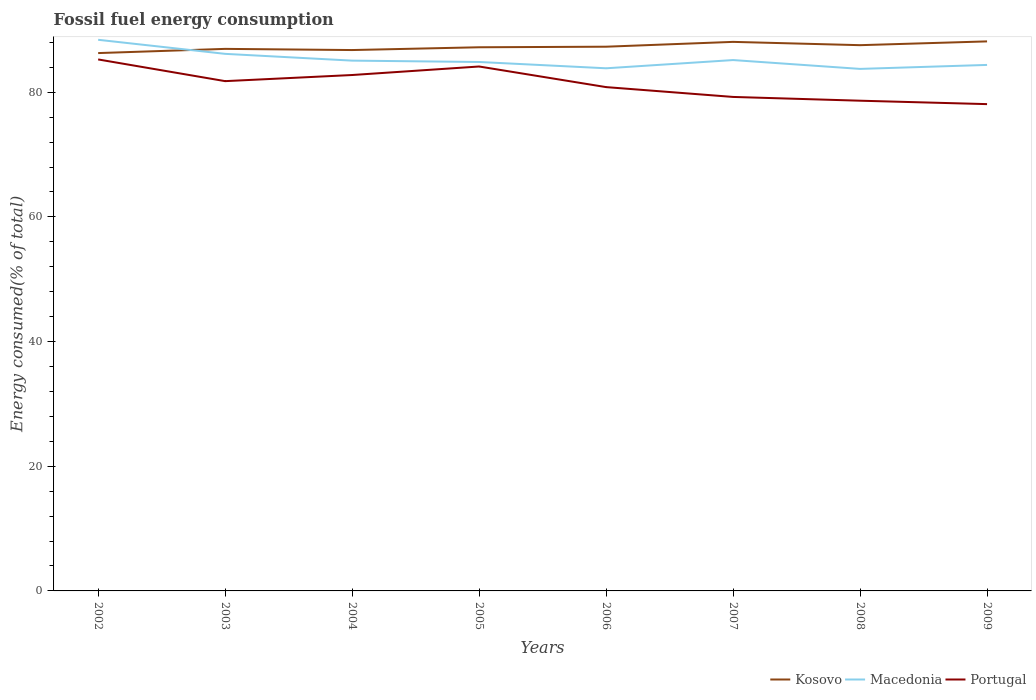Across all years, what is the maximum percentage of energy consumed in Portugal?
Make the answer very short. 78.09. What is the total percentage of energy consumed in Kosovo in the graph?
Provide a short and direct response. -0.08. What is the difference between the highest and the second highest percentage of energy consumed in Portugal?
Your response must be concise. 7.17. Is the percentage of energy consumed in Kosovo strictly greater than the percentage of energy consumed in Portugal over the years?
Ensure brevity in your answer.  No. How many years are there in the graph?
Make the answer very short. 8. How many legend labels are there?
Offer a terse response. 3. What is the title of the graph?
Your answer should be compact. Fossil fuel energy consumption. What is the label or title of the X-axis?
Your response must be concise. Years. What is the label or title of the Y-axis?
Your response must be concise. Energy consumed(% of total). What is the Energy consumed(% of total) in Kosovo in 2002?
Your response must be concise. 86.28. What is the Energy consumed(% of total) in Macedonia in 2002?
Provide a short and direct response. 88.41. What is the Energy consumed(% of total) in Portugal in 2002?
Your answer should be very brief. 85.26. What is the Energy consumed(% of total) of Kosovo in 2003?
Offer a very short reply. 86.95. What is the Energy consumed(% of total) of Macedonia in 2003?
Make the answer very short. 86.15. What is the Energy consumed(% of total) in Portugal in 2003?
Provide a succinct answer. 81.77. What is the Energy consumed(% of total) of Kosovo in 2004?
Your answer should be very brief. 86.76. What is the Energy consumed(% of total) in Macedonia in 2004?
Provide a short and direct response. 85.07. What is the Energy consumed(% of total) in Portugal in 2004?
Give a very brief answer. 82.76. What is the Energy consumed(% of total) of Kosovo in 2005?
Provide a succinct answer. 87.21. What is the Energy consumed(% of total) of Macedonia in 2005?
Give a very brief answer. 84.85. What is the Energy consumed(% of total) in Portugal in 2005?
Offer a terse response. 84.12. What is the Energy consumed(% of total) in Kosovo in 2006?
Offer a terse response. 87.3. What is the Energy consumed(% of total) of Macedonia in 2006?
Your answer should be very brief. 83.84. What is the Energy consumed(% of total) of Portugal in 2006?
Provide a short and direct response. 80.82. What is the Energy consumed(% of total) in Kosovo in 2007?
Ensure brevity in your answer.  88.07. What is the Energy consumed(% of total) of Macedonia in 2007?
Make the answer very short. 85.16. What is the Energy consumed(% of total) of Portugal in 2007?
Offer a very short reply. 79.24. What is the Energy consumed(% of total) of Kosovo in 2008?
Ensure brevity in your answer.  87.54. What is the Energy consumed(% of total) in Macedonia in 2008?
Your answer should be very brief. 83.74. What is the Energy consumed(% of total) of Portugal in 2008?
Give a very brief answer. 78.64. What is the Energy consumed(% of total) of Kosovo in 2009?
Provide a short and direct response. 88.15. What is the Energy consumed(% of total) of Macedonia in 2009?
Your answer should be very brief. 84.38. What is the Energy consumed(% of total) in Portugal in 2009?
Make the answer very short. 78.09. Across all years, what is the maximum Energy consumed(% of total) of Kosovo?
Offer a terse response. 88.15. Across all years, what is the maximum Energy consumed(% of total) of Macedonia?
Give a very brief answer. 88.41. Across all years, what is the maximum Energy consumed(% of total) in Portugal?
Offer a terse response. 85.26. Across all years, what is the minimum Energy consumed(% of total) in Kosovo?
Provide a succinct answer. 86.28. Across all years, what is the minimum Energy consumed(% of total) in Macedonia?
Your answer should be very brief. 83.74. Across all years, what is the minimum Energy consumed(% of total) of Portugal?
Provide a succinct answer. 78.09. What is the total Energy consumed(% of total) in Kosovo in the graph?
Provide a succinct answer. 698.26. What is the total Energy consumed(% of total) in Macedonia in the graph?
Make the answer very short. 681.58. What is the total Energy consumed(% of total) in Portugal in the graph?
Give a very brief answer. 650.69. What is the difference between the Energy consumed(% of total) in Kosovo in 2002 and that in 2003?
Keep it short and to the point. -0.68. What is the difference between the Energy consumed(% of total) in Macedonia in 2002 and that in 2003?
Your answer should be compact. 2.26. What is the difference between the Energy consumed(% of total) in Portugal in 2002 and that in 2003?
Give a very brief answer. 3.48. What is the difference between the Energy consumed(% of total) in Kosovo in 2002 and that in 2004?
Make the answer very short. -0.49. What is the difference between the Energy consumed(% of total) of Macedonia in 2002 and that in 2004?
Your answer should be compact. 3.34. What is the difference between the Energy consumed(% of total) in Portugal in 2002 and that in 2004?
Your answer should be compact. 2.5. What is the difference between the Energy consumed(% of total) of Kosovo in 2002 and that in 2005?
Keep it short and to the point. -0.93. What is the difference between the Energy consumed(% of total) in Macedonia in 2002 and that in 2005?
Offer a terse response. 3.56. What is the difference between the Energy consumed(% of total) of Portugal in 2002 and that in 2005?
Make the answer very short. 1.13. What is the difference between the Energy consumed(% of total) of Kosovo in 2002 and that in 2006?
Keep it short and to the point. -1.02. What is the difference between the Energy consumed(% of total) in Macedonia in 2002 and that in 2006?
Your response must be concise. 4.57. What is the difference between the Energy consumed(% of total) in Portugal in 2002 and that in 2006?
Keep it short and to the point. 4.44. What is the difference between the Energy consumed(% of total) of Kosovo in 2002 and that in 2007?
Offer a very short reply. -1.8. What is the difference between the Energy consumed(% of total) of Macedonia in 2002 and that in 2007?
Your answer should be very brief. 3.25. What is the difference between the Energy consumed(% of total) in Portugal in 2002 and that in 2007?
Your answer should be very brief. 6.02. What is the difference between the Energy consumed(% of total) of Kosovo in 2002 and that in 2008?
Your response must be concise. -1.27. What is the difference between the Energy consumed(% of total) in Macedonia in 2002 and that in 2008?
Keep it short and to the point. 4.67. What is the difference between the Energy consumed(% of total) in Portugal in 2002 and that in 2008?
Keep it short and to the point. 6.62. What is the difference between the Energy consumed(% of total) of Kosovo in 2002 and that in 2009?
Your answer should be very brief. -1.87. What is the difference between the Energy consumed(% of total) in Macedonia in 2002 and that in 2009?
Ensure brevity in your answer.  4.03. What is the difference between the Energy consumed(% of total) of Portugal in 2002 and that in 2009?
Your answer should be compact. 7.17. What is the difference between the Energy consumed(% of total) of Kosovo in 2003 and that in 2004?
Provide a short and direct response. 0.19. What is the difference between the Energy consumed(% of total) of Macedonia in 2003 and that in 2004?
Provide a succinct answer. 1.09. What is the difference between the Energy consumed(% of total) in Portugal in 2003 and that in 2004?
Your response must be concise. -0.98. What is the difference between the Energy consumed(% of total) in Kosovo in 2003 and that in 2005?
Make the answer very short. -0.26. What is the difference between the Energy consumed(% of total) of Macedonia in 2003 and that in 2005?
Your answer should be compact. 1.31. What is the difference between the Energy consumed(% of total) of Portugal in 2003 and that in 2005?
Give a very brief answer. -2.35. What is the difference between the Energy consumed(% of total) of Kosovo in 2003 and that in 2006?
Provide a succinct answer. -0.35. What is the difference between the Energy consumed(% of total) in Macedonia in 2003 and that in 2006?
Your response must be concise. 2.32. What is the difference between the Energy consumed(% of total) in Kosovo in 2003 and that in 2007?
Make the answer very short. -1.12. What is the difference between the Energy consumed(% of total) of Portugal in 2003 and that in 2007?
Your answer should be very brief. 2.53. What is the difference between the Energy consumed(% of total) in Kosovo in 2003 and that in 2008?
Offer a terse response. -0.59. What is the difference between the Energy consumed(% of total) in Macedonia in 2003 and that in 2008?
Ensure brevity in your answer.  2.41. What is the difference between the Energy consumed(% of total) in Portugal in 2003 and that in 2008?
Provide a short and direct response. 3.14. What is the difference between the Energy consumed(% of total) of Kosovo in 2003 and that in 2009?
Give a very brief answer. -1.2. What is the difference between the Energy consumed(% of total) of Macedonia in 2003 and that in 2009?
Your answer should be compact. 1.78. What is the difference between the Energy consumed(% of total) of Portugal in 2003 and that in 2009?
Your answer should be compact. 3.69. What is the difference between the Energy consumed(% of total) of Kosovo in 2004 and that in 2005?
Ensure brevity in your answer.  -0.45. What is the difference between the Energy consumed(% of total) of Macedonia in 2004 and that in 2005?
Your response must be concise. 0.22. What is the difference between the Energy consumed(% of total) of Portugal in 2004 and that in 2005?
Make the answer very short. -1.37. What is the difference between the Energy consumed(% of total) of Kosovo in 2004 and that in 2006?
Keep it short and to the point. -0.54. What is the difference between the Energy consumed(% of total) of Macedonia in 2004 and that in 2006?
Provide a succinct answer. 1.23. What is the difference between the Energy consumed(% of total) of Portugal in 2004 and that in 2006?
Give a very brief answer. 1.94. What is the difference between the Energy consumed(% of total) of Kosovo in 2004 and that in 2007?
Your answer should be very brief. -1.31. What is the difference between the Energy consumed(% of total) of Macedonia in 2004 and that in 2007?
Provide a short and direct response. -0.09. What is the difference between the Energy consumed(% of total) in Portugal in 2004 and that in 2007?
Offer a terse response. 3.52. What is the difference between the Energy consumed(% of total) in Kosovo in 2004 and that in 2008?
Provide a short and direct response. -0.78. What is the difference between the Energy consumed(% of total) in Macedonia in 2004 and that in 2008?
Make the answer very short. 1.33. What is the difference between the Energy consumed(% of total) in Portugal in 2004 and that in 2008?
Give a very brief answer. 4.12. What is the difference between the Energy consumed(% of total) in Kosovo in 2004 and that in 2009?
Your answer should be compact. -1.39. What is the difference between the Energy consumed(% of total) of Macedonia in 2004 and that in 2009?
Make the answer very short. 0.69. What is the difference between the Energy consumed(% of total) of Portugal in 2004 and that in 2009?
Your answer should be compact. 4.67. What is the difference between the Energy consumed(% of total) in Kosovo in 2005 and that in 2006?
Make the answer very short. -0.09. What is the difference between the Energy consumed(% of total) in Portugal in 2005 and that in 2006?
Offer a terse response. 3.31. What is the difference between the Energy consumed(% of total) of Kosovo in 2005 and that in 2007?
Your answer should be compact. -0.87. What is the difference between the Energy consumed(% of total) of Macedonia in 2005 and that in 2007?
Make the answer very short. -0.31. What is the difference between the Energy consumed(% of total) of Portugal in 2005 and that in 2007?
Your answer should be compact. 4.88. What is the difference between the Energy consumed(% of total) in Kosovo in 2005 and that in 2008?
Provide a succinct answer. -0.33. What is the difference between the Energy consumed(% of total) in Macedonia in 2005 and that in 2008?
Provide a succinct answer. 1.11. What is the difference between the Energy consumed(% of total) in Portugal in 2005 and that in 2008?
Keep it short and to the point. 5.49. What is the difference between the Energy consumed(% of total) in Kosovo in 2005 and that in 2009?
Your answer should be compact. -0.94. What is the difference between the Energy consumed(% of total) of Macedonia in 2005 and that in 2009?
Keep it short and to the point. 0.47. What is the difference between the Energy consumed(% of total) in Portugal in 2005 and that in 2009?
Your answer should be compact. 6.03. What is the difference between the Energy consumed(% of total) of Kosovo in 2006 and that in 2007?
Provide a succinct answer. -0.77. What is the difference between the Energy consumed(% of total) of Macedonia in 2006 and that in 2007?
Your answer should be very brief. -1.32. What is the difference between the Energy consumed(% of total) of Portugal in 2006 and that in 2007?
Offer a terse response. 1.58. What is the difference between the Energy consumed(% of total) in Kosovo in 2006 and that in 2008?
Provide a succinct answer. -0.24. What is the difference between the Energy consumed(% of total) of Macedonia in 2006 and that in 2008?
Make the answer very short. 0.1. What is the difference between the Energy consumed(% of total) of Portugal in 2006 and that in 2008?
Offer a terse response. 2.18. What is the difference between the Energy consumed(% of total) in Kosovo in 2006 and that in 2009?
Ensure brevity in your answer.  -0.85. What is the difference between the Energy consumed(% of total) in Macedonia in 2006 and that in 2009?
Your answer should be very brief. -0.54. What is the difference between the Energy consumed(% of total) of Portugal in 2006 and that in 2009?
Provide a succinct answer. 2.73. What is the difference between the Energy consumed(% of total) of Kosovo in 2007 and that in 2008?
Your answer should be very brief. 0.53. What is the difference between the Energy consumed(% of total) of Macedonia in 2007 and that in 2008?
Offer a terse response. 1.42. What is the difference between the Energy consumed(% of total) in Portugal in 2007 and that in 2008?
Offer a terse response. 0.6. What is the difference between the Energy consumed(% of total) of Kosovo in 2007 and that in 2009?
Ensure brevity in your answer.  -0.08. What is the difference between the Energy consumed(% of total) of Macedonia in 2007 and that in 2009?
Your answer should be very brief. 0.78. What is the difference between the Energy consumed(% of total) in Portugal in 2007 and that in 2009?
Provide a succinct answer. 1.15. What is the difference between the Energy consumed(% of total) of Kosovo in 2008 and that in 2009?
Provide a short and direct response. -0.61. What is the difference between the Energy consumed(% of total) in Macedonia in 2008 and that in 2009?
Offer a terse response. -0.64. What is the difference between the Energy consumed(% of total) in Portugal in 2008 and that in 2009?
Offer a very short reply. 0.55. What is the difference between the Energy consumed(% of total) of Kosovo in 2002 and the Energy consumed(% of total) of Macedonia in 2003?
Provide a succinct answer. 0.12. What is the difference between the Energy consumed(% of total) in Kosovo in 2002 and the Energy consumed(% of total) in Portugal in 2003?
Your response must be concise. 4.5. What is the difference between the Energy consumed(% of total) of Macedonia in 2002 and the Energy consumed(% of total) of Portugal in 2003?
Provide a short and direct response. 6.63. What is the difference between the Energy consumed(% of total) in Kosovo in 2002 and the Energy consumed(% of total) in Macedonia in 2004?
Your answer should be compact. 1.21. What is the difference between the Energy consumed(% of total) in Kosovo in 2002 and the Energy consumed(% of total) in Portugal in 2004?
Your response must be concise. 3.52. What is the difference between the Energy consumed(% of total) in Macedonia in 2002 and the Energy consumed(% of total) in Portugal in 2004?
Give a very brief answer. 5.65. What is the difference between the Energy consumed(% of total) in Kosovo in 2002 and the Energy consumed(% of total) in Macedonia in 2005?
Provide a succinct answer. 1.43. What is the difference between the Energy consumed(% of total) of Kosovo in 2002 and the Energy consumed(% of total) of Portugal in 2005?
Your response must be concise. 2.15. What is the difference between the Energy consumed(% of total) in Macedonia in 2002 and the Energy consumed(% of total) in Portugal in 2005?
Give a very brief answer. 4.29. What is the difference between the Energy consumed(% of total) of Kosovo in 2002 and the Energy consumed(% of total) of Macedonia in 2006?
Make the answer very short. 2.44. What is the difference between the Energy consumed(% of total) of Kosovo in 2002 and the Energy consumed(% of total) of Portugal in 2006?
Provide a short and direct response. 5.46. What is the difference between the Energy consumed(% of total) in Macedonia in 2002 and the Energy consumed(% of total) in Portugal in 2006?
Offer a very short reply. 7.59. What is the difference between the Energy consumed(% of total) in Kosovo in 2002 and the Energy consumed(% of total) in Macedonia in 2007?
Provide a short and direct response. 1.12. What is the difference between the Energy consumed(% of total) of Kosovo in 2002 and the Energy consumed(% of total) of Portugal in 2007?
Provide a short and direct response. 7.04. What is the difference between the Energy consumed(% of total) in Macedonia in 2002 and the Energy consumed(% of total) in Portugal in 2007?
Your answer should be compact. 9.17. What is the difference between the Energy consumed(% of total) of Kosovo in 2002 and the Energy consumed(% of total) of Macedonia in 2008?
Your response must be concise. 2.54. What is the difference between the Energy consumed(% of total) of Kosovo in 2002 and the Energy consumed(% of total) of Portugal in 2008?
Provide a succinct answer. 7.64. What is the difference between the Energy consumed(% of total) of Macedonia in 2002 and the Energy consumed(% of total) of Portugal in 2008?
Your answer should be compact. 9.77. What is the difference between the Energy consumed(% of total) of Kosovo in 2002 and the Energy consumed(% of total) of Macedonia in 2009?
Offer a very short reply. 1.9. What is the difference between the Energy consumed(% of total) in Kosovo in 2002 and the Energy consumed(% of total) in Portugal in 2009?
Your response must be concise. 8.19. What is the difference between the Energy consumed(% of total) of Macedonia in 2002 and the Energy consumed(% of total) of Portugal in 2009?
Make the answer very short. 10.32. What is the difference between the Energy consumed(% of total) in Kosovo in 2003 and the Energy consumed(% of total) in Macedonia in 2004?
Make the answer very short. 1.89. What is the difference between the Energy consumed(% of total) in Kosovo in 2003 and the Energy consumed(% of total) in Portugal in 2004?
Your response must be concise. 4.2. What is the difference between the Energy consumed(% of total) of Macedonia in 2003 and the Energy consumed(% of total) of Portugal in 2004?
Offer a very short reply. 3.4. What is the difference between the Energy consumed(% of total) in Kosovo in 2003 and the Energy consumed(% of total) in Macedonia in 2005?
Provide a succinct answer. 2.1. What is the difference between the Energy consumed(% of total) of Kosovo in 2003 and the Energy consumed(% of total) of Portugal in 2005?
Offer a very short reply. 2.83. What is the difference between the Energy consumed(% of total) in Macedonia in 2003 and the Energy consumed(% of total) in Portugal in 2005?
Give a very brief answer. 2.03. What is the difference between the Energy consumed(% of total) of Kosovo in 2003 and the Energy consumed(% of total) of Macedonia in 2006?
Offer a very short reply. 3.11. What is the difference between the Energy consumed(% of total) of Kosovo in 2003 and the Energy consumed(% of total) of Portugal in 2006?
Make the answer very short. 6.13. What is the difference between the Energy consumed(% of total) of Macedonia in 2003 and the Energy consumed(% of total) of Portugal in 2006?
Your answer should be compact. 5.34. What is the difference between the Energy consumed(% of total) of Kosovo in 2003 and the Energy consumed(% of total) of Macedonia in 2007?
Provide a short and direct response. 1.8. What is the difference between the Energy consumed(% of total) in Kosovo in 2003 and the Energy consumed(% of total) in Portugal in 2007?
Provide a short and direct response. 7.71. What is the difference between the Energy consumed(% of total) of Macedonia in 2003 and the Energy consumed(% of total) of Portugal in 2007?
Make the answer very short. 6.91. What is the difference between the Energy consumed(% of total) of Kosovo in 2003 and the Energy consumed(% of total) of Macedonia in 2008?
Your answer should be compact. 3.21. What is the difference between the Energy consumed(% of total) in Kosovo in 2003 and the Energy consumed(% of total) in Portugal in 2008?
Keep it short and to the point. 8.31. What is the difference between the Energy consumed(% of total) in Macedonia in 2003 and the Energy consumed(% of total) in Portugal in 2008?
Ensure brevity in your answer.  7.51. What is the difference between the Energy consumed(% of total) of Kosovo in 2003 and the Energy consumed(% of total) of Macedonia in 2009?
Your answer should be compact. 2.58. What is the difference between the Energy consumed(% of total) in Kosovo in 2003 and the Energy consumed(% of total) in Portugal in 2009?
Your response must be concise. 8.86. What is the difference between the Energy consumed(% of total) in Macedonia in 2003 and the Energy consumed(% of total) in Portugal in 2009?
Provide a short and direct response. 8.06. What is the difference between the Energy consumed(% of total) in Kosovo in 2004 and the Energy consumed(% of total) in Macedonia in 2005?
Make the answer very short. 1.91. What is the difference between the Energy consumed(% of total) of Kosovo in 2004 and the Energy consumed(% of total) of Portugal in 2005?
Keep it short and to the point. 2.64. What is the difference between the Energy consumed(% of total) in Macedonia in 2004 and the Energy consumed(% of total) in Portugal in 2005?
Your response must be concise. 0.94. What is the difference between the Energy consumed(% of total) in Kosovo in 2004 and the Energy consumed(% of total) in Macedonia in 2006?
Give a very brief answer. 2.92. What is the difference between the Energy consumed(% of total) of Kosovo in 2004 and the Energy consumed(% of total) of Portugal in 2006?
Your response must be concise. 5.94. What is the difference between the Energy consumed(% of total) of Macedonia in 2004 and the Energy consumed(% of total) of Portugal in 2006?
Ensure brevity in your answer.  4.25. What is the difference between the Energy consumed(% of total) of Kosovo in 2004 and the Energy consumed(% of total) of Macedonia in 2007?
Keep it short and to the point. 1.61. What is the difference between the Energy consumed(% of total) in Kosovo in 2004 and the Energy consumed(% of total) in Portugal in 2007?
Offer a terse response. 7.52. What is the difference between the Energy consumed(% of total) of Macedonia in 2004 and the Energy consumed(% of total) of Portugal in 2007?
Make the answer very short. 5.82. What is the difference between the Energy consumed(% of total) of Kosovo in 2004 and the Energy consumed(% of total) of Macedonia in 2008?
Ensure brevity in your answer.  3.02. What is the difference between the Energy consumed(% of total) in Kosovo in 2004 and the Energy consumed(% of total) in Portugal in 2008?
Offer a very short reply. 8.12. What is the difference between the Energy consumed(% of total) of Macedonia in 2004 and the Energy consumed(% of total) of Portugal in 2008?
Provide a short and direct response. 6.43. What is the difference between the Energy consumed(% of total) of Kosovo in 2004 and the Energy consumed(% of total) of Macedonia in 2009?
Offer a terse response. 2.39. What is the difference between the Energy consumed(% of total) in Kosovo in 2004 and the Energy consumed(% of total) in Portugal in 2009?
Your answer should be compact. 8.67. What is the difference between the Energy consumed(% of total) in Macedonia in 2004 and the Energy consumed(% of total) in Portugal in 2009?
Keep it short and to the point. 6.98. What is the difference between the Energy consumed(% of total) in Kosovo in 2005 and the Energy consumed(% of total) in Macedonia in 2006?
Your response must be concise. 3.37. What is the difference between the Energy consumed(% of total) in Kosovo in 2005 and the Energy consumed(% of total) in Portugal in 2006?
Give a very brief answer. 6.39. What is the difference between the Energy consumed(% of total) of Macedonia in 2005 and the Energy consumed(% of total) of Portugal in 2006?
Your response must be concise. 4.03. What is the difference between the Energy consumed(% of total) in Kosovo in 2005 and the Energy consumed(% of total) in Macedonia in 2007?
Give a very brief answer. 2.05. What is the difference between the Energy consumed(% of total) in Kosovo in 2005 and the Energy consumed(% of total) in Portugal in 2007?
Your response must be concise. 7.97. What is the difference between the Energy consumed(% of total) of Macedonia in 2005 and the Energy consumed(% of total) of Portugal in 2007?
Offer a terse response. 5.61. What is the difference between the Energy consumed(% of total) of Kosovo in 2005 and the Energy consumed(% of total) of Macedonia in 2008?
Offer a very short reply. 3.47. What is the difference between the Energy consumed(% of total) in Kosovo in 2005 and the Energy consumed(% of total) in Portugal in 2008?
Your answer should be very brief. 8.57. What is the difference between the Energy consumed(% of total) of Macedonia in 2005 and the Energy consumed(% of total) of Portugal in 2008?
Make the answer very short. 6.21. What is the difference between the Energy consumed(% of total) of Kosovo in 2005 and the Energy consumed(% of total) of Macedonia in 2009?
Keep it short and to the point. 2.83. What is the difference between the Energy consumed(% of total) in Kosovo in 2005 and the Energy consumed(% of total) in Portugal in 2009?
Ensure brevity in your answer.  9.12. What is the difference between the Energy consumed(% of total) of Macedonia in 2005 and the Energy consumed(% of total) of Portugal in 2009?
Offer a terse response. 6.76. What is the difference between the Energy consumed(% of total) in Kosovo in 2006 and the Energy consumed(% of total) in Macedonia in 2007?
Provide a short and direct response. 2.14. What is the difference between the Energy consumed(% of total) of Kosovo in 2006 and the Energy consumed(% of total) of Portugal in 2007?
Make the answer very short. 8.06. What is the difference between the Energy consumed(% of total) in Macedonia in 2006 and the Energy consumed(% of total) in Portugal in 2007?
Your answer should be very brief. 4.6. What is the difference between the Energy consumed(% of total) of Kosovo in 2006 and the Energy consumed(% of total) of Macedonia in 2008?
Provide a short and direct response. 3.56. What is the difference between the Energy consumed(% of total) of Kosovo in 2006 and the Energy consumed(% of total) of Portugal in 2008?
Your answer should be very brief. 8.66. What is the difference between the Energy consumed(% of total) of Macedonia in 2006 and the Energy consumed(% of total) of Portugal in 2008?
Give a very brief answer. 5.2. What is the difference between the Energy consumed(% of total) in Kosovo in 2006 and the Energy consumed(% of total) in Macedonia in 2009?
Your answer should be compact. 2.92. What is the difference between the Energy consumed(% of total) of Kosovo in 2006 and the Energy consumed(% of total) of Portugal in 2009?
Your answer should be very brief. 9.21. What is the difference between the Energy consumed(% of total) in Macedonia in 2006 and the Energy consumed(% of total) in Portugal in 2009?
Your answer should be compact. 5.75. What is the difference between the Energy consumed(% of total) in Kosovo in 2007 and the Energy consumed(% of total) in Macedonia in 2008?
Keep it short and to the point. 4.34. What is the difference between the Energy consumed(% of total) of Kosovo in 2007 and the Energy consumed(% of total) of Portugal in 2008?
Keep it short and to the point. 9.44. What is the difference between the Energy consumed(% of total) in Macedonia in 2007 and the Energy consumed(% of total) in Portugal in 2008?
Provide a short and direct response. 6.52. What is the difference between the Energy consumed(% of total) in Kosovo in 2007 and the Energy consumed(% of total) in Macedonia in 2009?
Keep it short and to the point. 3.7. What is the difference between the Energy consumed(% of total) of Kosovo in 2007 and the Energy consumed(% of total) of Portugal in 2009?
Provide a succinct answer. 9.99. What is the difference between the Energy consumed(% of total) of Macedonia in 2007 and the Energy consumed(% of total) of Portugal in 2009?
Make the answer very short. 7.07. What is the difference between the Energy consumed(% of total) in Kosovo in 2008 and the Energy consumed(% of total) in Macedonia in 2009?
Provide a short and direct response. 3.17. What is the difference between the Energy consumed(% of total) of Kosovo in 2008 and the Energy consumed(% of total) of Portugal in 2009?
Your answer should be compact. 9.45. What is the difference between the Energy consumed(% of total) of Macedonia in 2008 and the Energy consumed(% of total) of Portugal in 2009?
Make the answer very short. 5.65. What is the average Energy consumed(% of total) in Kosovo per year?
Ensure brevity in your answer.  87.28. What is the average Energy consumed(% of total) of Macedonia per year?
Provide a short and direct response. 85.2. What is the average Energy consumed(% of total) in Portugal per year?
Offer a very short reply. 81.34. In the year 2002, what is the difference between the Energy consumed(% of total) in Kosovo and Energy consumed(% of total) in Macedonia?
Your answer should be very brief. -2.13. In the year 2002, what is the difference between the Energy consumed(% of total) of Kosovo and Energy consumed(% of total) of Portugal?
Keep it short and to the point. 1.02. In the year 2002, what is the difference between the Energy consumed(% of total) in Macedonia and Energy consumed(% of total) in Portugal?
Your answer should be compact. 3.15. In the year 2003, what is the difference between the Energy consumed(% of total) in Kosovo and Energy consumed(% of total) in Macedonia?
Your answer should be compact. 0.8. In the year 2003, what is the difference between the Energy consumed(% of total) in Kosovo and Energy consumed(% of total) in Portugal?
Provide a short and direct response. 5.18. In the year 2003, what is the difference between the Energy consumed(% of total) in Macedonia and Energy consumed(% of total) in Portugal?
Your answer should be very brief. 4.38. In the year 2004, what is the difference between the Energy consumed(% of total) in Kosovo and Energy consumed(% of total) in Macedonia?
Provide a short and direct response. 1.7. In the year 2004, what is the difference between the Energy consumed(% of total) in Kosovo and Energy consumed(% of total) in Portugal?
Offer a very short reply. 4.01. In the year 2004, what is the difference between the Energy consumed(% of total) in Macedonia and Energy consumed(% of total) in Portugal?
Ensure brevity in your answer.  2.31. In the year 2005, what is the difference between the Energy consumed(% of total) in Kosovo and Energy consumed(% of total) in Macedonia?
Make the answer very short. 2.36. In the year 2005, what is the difference between the Energy consumed(% of total) of Kosovo and Energy consumed(% of total) of Portugal?
Ensure brevity in your answer.  3.09. In the year 2005, what is the difference between the Energy consumed(% of total) of Macedonia and Energy consumed(% of total) of Portugal?
Your answer should be very brief. 0.72. In the year 2006, what is the difference between the Energy consumed(% of total) in Kosovo and Energy consumed(% of total) in Macedonia?
Make the answer very short. 3.46. In the year 2006, what is the difference between the Energy consumed(% of total) in Kosovo and Energy consumed(% of total) in Portugal?
Offer a very short reply. 6.48. In the year 2006, what is the difference between the Energy consumed(% of total) in Macedonia and Energy consumed(% of total) in Portugal?
Give a very brief answer. 3.02. In the year 2007, what is the difference between the Energy consumed(% of total) of Kosovo and Energy consumed(% of total) of Macedonia?
Give a very brief answer. 2.92. In the year 2007, what is the difference between the Energy consumed(% of total) of Kosovo and Energy consumed(% of total) of Portugal?
Provide a succinct answer. 8.83. In the year 2007, what is the difference between the Energy consumed(% of total) of Macedonia and Energy consumed(% of total) of Portugal?
Keep it short and to the point. 5.91. In the year 2008, what is the difference between the Energy consumed(% of total) in Kosovo and Energy consumed(% of total) in Macedonia?
Provide a succinct answer. 3.8. In the year 2008, what is the difference between the Energy consumed(% of total) in Kosovo and Energy consumed(% of total) in Portugal?
Your answer should be very brief. 8.91. In the year 2008, what is the difference between the Energy consumed(% of total) in Macedonia and Energy consumed(% of total) in Portugal?
Your answer should be compact. 5.1. In the year 2009, what is the difference between the Energy consumed(% of total) of Kosovo and Energy consumed(% of total) of Macedonia?
Your response must be concise. 3.78. In the year 2009, what is the difference between the Energy consumed(% of total) in Kosovo and Energy consumed(% of total) in Portugal?
Give a very brief answer. 10.06. In the year 2009, what is the difference between the Energy consumed(% of total) of Macedonia and Energy consumed(% of total) of Portugal?
Give a very brief answer. 6.29. What is the ratio of the Energy consumed(% of total) in Kosovo in 2002 to that in 2003?
Your answer should be compact. 0.99. What is the ratio of the Energy consumed(% of total) of Macedonia in 2002 to that in 2003?
Keep it short and to the point. 1.03. What is the ratio of the Energy consumed(% of total) in Portugal in 2002 to that in 2003?
Give a very brief answer. 1.04. What is the ratio of the Energy consumed(% of total) in Macedonia in 2002 to that in 2004?
Provide a succinct answer. 1.04. What is the ratio of the Energy consumed(% of total) in Portugal in 2002 to that in 2004?
Provide a short and direct response. 1.03. What is the ratio of the Energy consumed(% of total) of Kosovo in 2002 to that in 2005?
Your response must be concise. 0.99. What is the ratio of the Energy consumed(% of total) in Macedonia in 2002 to that in 2005?
Provide a short and direct response. 1.04. What is the ratio of the Energy consumed(% of total) of Portugal in 2002 to that in 2005?
Make the answer very short. 1.01. What is the ratio of the Energy consumed(% of total) in Kosovo in 2002 to that in 2006?
Offer a very short reply. 0.99. What is the ratio of the Energy consumed(% of total) in Macedonia in 2002 to that in 2006?
Offer a very short reply. 1.05. What is the ratio of the Energy consumed(% of total) of Portugal in 2002 to that in 2006?
Offer a terse response. 1.05. What is the ratio of the Energy consumed(% of total) of Kosovo in 2002 to that in 2007?
Give a very brief answer. 0.98. What is the ratio of the Energy consumed(% of total) in Macedonia in 2002 to that in 2007?
Provide a short and direct response. 1.04. What is the ratio of the Energy consumed(% of total) of Portugal in 2002 to that in 2007?
Your answer should be compact. 1.08. What is the ratio of the Energy consumed(% of total) of Kosovo in 2002 to that in 2008?
Offer a very short reply. 0.99. What is the ratio of the Energy consumed(% of total) of Macedonia in 2002 to that in 2008?
Give a very brief answer. 1.06. What is the ratio of the Energy consumed(% of total) in Portugal in 2002 to that in 2008?
Your answer should be compact. 1.08. What is the ratio of the Energy consumed(% of total) of Kosovo in 2002 to that in 2009?
Keep it short and to the point. 0.98. What is the ratio of the Energy consumed(% of total) in Macedonia in 2002 to that in 2009?
Offer a terse response. 1.05. What is the ratio of the Energy consumed(% of total) of Portugal in 2002 to that in 2009?
Offer a terse response. 1.09. What is the ratio of the Energy consumed(% of total) in Kosovo in 2003 to that in 2004?
Offer a terse response. 1. What is the ratio of the Energy consumed(% of total) in Macedonia in 2003 to that in 2004?
Provide a succinct answer. 1.01. What is the ratio of the Energy consumed(% of total) in Kosovo in 2003 to that in 2005?
Provide a succinct answer. 1. What is the ratio of the Energy consumed(% of total) of Macedonia in 2003 to that in 2005?
Provide a short and direct response. 1.02. What is the ratio of the Energy consumed(% of total) of Portugal in 2003 to that in 2005?
Keep it short and to the point. 0.97. What is the ratio of the Energy consumed(% of total) of Macedonia in 2003 to that in 2006?
Make the answer very short. 1.03. What is the ratio of the Energy consumed(% of total) of Portugal in 2003 to that in 2006?
Your response must be concise. 1.01. What is the ratio of the Energy consumed(% of total) of Kosovo in 2003 to that in 2007?
Keep it short and to the point. 0.99. What is the ratio of the Energy consumed(% of total) in Macedonia in 2003 to that in 2007?
Offer a terse response. 1.01. What is the ratio of the Energy consumed(% of total) in Portugal in 2003 to that in 2007?
Make the answer very short. 1.03. What is the ratio of the Energy consumed(% of total) in Macedonia in 2003 to that in 2008?
Give a very brief answer. 1.03. What is the ratio of the Energy consumed(% of total) in Portugal in 2003 to that in 2008?
Make the answer very short. 1.04. What is the ratio of the Energy consumed(% of total) of Kosovo in 2003 to that in 2009?
Offer a very short reply. 0.99. What is the ratio of the Energy consumed(% of total) in Macedonia in 2003 to that in 2009?
Your answer should be compact. 1.02. What is the ratio of the Energy consumed(% of total) in Portugal in 2003 to that in 2009?
Make the answer very short. 1.05. What is the ratio of the Energy consumed(% of total) in Portugal in 2004 to that in 2005?
Your response must be concise. 0.98. What is the ratio of the Energy consumed(% of total) in Kosovo in 2004 to that in 2006?
Give a very brief answer. 0.99. What is the ratio of the Energy consumed(% of total) in Macedonia in 2004 to that in 2006?
Offer a terse response. 1.01. What is the ratio of the Energy consumed(% of total) in Portugal in 2004 to that in 2006?
Offer a very short reply. 1.02. What is the ratio of the Energy consumed(% of total) in Kosovo in 2004 to that in 2007?
Your answer should be compact. 0.99. What is the ratio of the Energy consumed(% of total) in Macedonia in 2004 to that in 2007?
Provide a short and direct response. 1. What is the ratio of the Energy consumed(% of total) in Portugal in 2004 to that in 2007?
Provide a short and direct response. 1.04. What is the ratio of the Energy consumed(% of total) in Macedonia in 2004 to that in 2008?
Offer a very short reply. 1.02. What is the ratio of the Energy consumed(% of total) of Portugal in 2004 to that in 2008?
Provide a short and direct response. 1.05. What is the ratio of the Energy consumed(% of total) in Kosovo in 2004 to that in 2009?
Ensure brevity in your answer.  0.98. What is the ratio of the Energy consumed(% of total) of Macedonia in 2004 to that in 2009?
Offer a terse response. 1.01. What is the ratio of the Energy consumed(% of total) of Portugal in 2004 to that in 2009?
Your answer should be very brief. 1.06. What is the ratio of the Energy consumed(% of total) in Macedonia in 2005 to that in 2006?
Provide a short and direct response. 1.01. What is the ratio of the Energy consumed(% of total) in Portugal in 2005 to that in 2006?
Provide a short and direct response. 1.04. What is the ratio of the Energy consumed(% of total) in Kosovo in 2005 to that in 2007?
Make the answer very short. 0.99. What is the ratio of the Energy consumed(% of total) of Macedonia in 2005 to that in 2007?
Provide a short and direct response. 1. What is the ratio of the Energy consumed(% of total) in Portugal in 2005 to that in 2007?
Make the answer very short. 1.06. What is the ratio of the Energy consumed(% of total) of Macedonia in 2005 to that in 2008?
Your response must be concise. 1.01. What is the ratio of the Energy consumed(% of total) in Portugal in 2005 to that in 2008?
Your answer should be compact. 1.07. What is the ratio of the Energy consumed(% of total) of Kosovo in 2005 to that in 2009?
Provide a succinct answer. 0.99. What is the ratio of the Energy consumed(% of total) in Macedonia in 2005 to that in 2009?
Provide a short and direct response. 1.01. What is the ratio of the Energy consumed(% of total) of Portugal in 2005 to that in 2009?
Give a very brief answer. 1.08. What is the ratio of the Energy consumed(% of total) of Macedonia in 2006 to that in 2007?
Provide a succinct answer. 0.98. What is the ratio of the Energy consumed(% of total) of Portugal in 2006 to that in 2007?
Make the answer very short. 1.02. What is the ratio of the Energy consumed(% of total) in Macedonia in 2006 to that in 2008?
Provide a succinct answer. 1. What is the ratio of the Energy consumed(% of total) in Portugal in 2006 to that in 2008?
Provide a short and direct response. 1.03. What is the ratio of the Energy consumed(% of total) of Kosovo in 2006 to that in 2009?
Your answer should be compact. 0.99. What is the ratio of the Energy consumed(% of total) of Macedonia in 2006 to that in 2009?
Provide a short and direct response. 0.99. What is the ratio of the Energy consumed(% of total) of Portugal in 2006 to that in 2009?
Ensure brevity in your answer.  1.03. What is the ratio of the Energy consumed(% of total) of Kosovo in 2007 to that in 2008?
Keep it short and to the point. 1.01. What is the ratio of the Energy consumed(% of total) in Macedonia in 2007 to that in 2008?
Keep it short and to the point. 1.02. What is the ratio of the Energy consumed(% of total) of Portugal in 2007 to that in 2008?
Your response must be concise. 1.01. What is the ratio of the Energy consumed(% of total) of Macedonia in 2007 to that in 2009?
Your answer should be compact. 1.01. What is the ratio of the Energy consumed(% of total) of Portugal in 2007 to that in 2009?
Provide a short and direct response. 1.01. What is the ratio of the Energy consumed(% of total) in Kosovo in 2008 to that in 2009?
Provide a short and direct response. 0.99. What is the ratio of the Energy consumed(% of total) in Portugal in 2008 to that in 2009?
Offer a very short reply. 1.01. What is the difference between the highest and the second highest Energy consumed(% of total) of Kosovo?
Offer a very short reply. 0.08. What is the difference between the highest and the second highest Energy consumed(% of total) of Macedonia?
Provide a short and direct response. 2.26. What is the difference between the highest and the second highest Energy consumed(% of total) in Portugal?
Make the answer very short. 1.13. What is the difference between the highest and the lowest Energy consumed(% of total) of Kosovo?
Provide a succinct answer. 1.87. What is the difference between the highest and the lowest Energy consumed(% of total) in Macedonia?
Make the answer very short. 4.67. What is the difference between the highest and the lowest Energy consumed(% of total) in Portugal?
Provide a short and direct response. 7.17. 